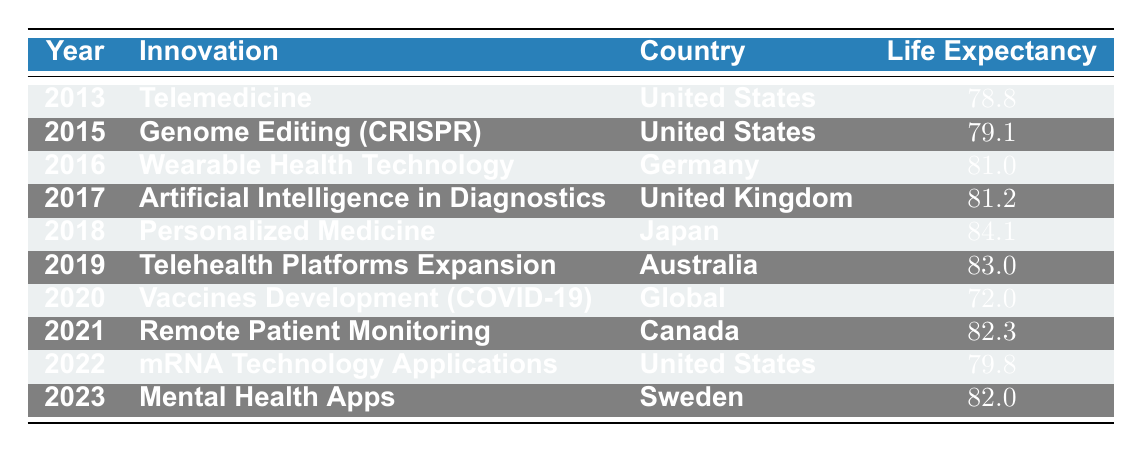What is the life expectancy in 2018? The table indicates that for the year 2018, the life expectancy associated with the innovation "Personalized Medicine" in Japan is 84.1.
Answer: 84.1 Which country introduced "Telemedicine" and what was the life expectancy at that time? According to the table, the United States introduced "Telemedicine" in 2013 with a life expectancy of 78.8.
Answer: United States, 78.8 Is the life expectancy in 2020 higher than in 2019? By comparing the life expectancies listed, in 2020 life expectancy was 72.0, while in 2019 it was 83.0, thus 72.0 is not higher than 83.0.
Answer: No What is the average life expectancy of all innovations listed for the year 2021 and later? The life expectancies for 2021 (82.3), 2022 (79.8), and 2023 (82.0) sum up to 244.1. There are three data points, so the average is 244.1/3 = 81.37.
Answer: 81.37 Which innovation had the highest life expectancy and what was that value? Looking through the table, the innovation with the highest life expectancy is "Personalized Medicine" in Japan in 2018, which is 84.1.
Answer: 84.1 Did "Wearable Health Technology" result in a life expectancy greater than 80? The table shows that "Wearable Health Technology" in 2016 had a life expectancy of 81.0, which is indeed greater than 80.
Answer: Yes What is the difference in life expectancy between the years 2018 and 2021? From the table, in 2018, the life expectancy was 84.1, while in 2021 it was 82.3. To find the difference: 84.1 - 82.3 = 1.8.
Answer: 1.8 Was "Genome Editing (CRISPR)" introduced in a year where life expectancy was below 80? The table indicates that "Genome Editing (CRISPR)" was introduced in 2015 with a life expectancy of 79.1, which is below 80.
Answer: Yes How many innovations resulted in a life expectancy of 80 or above from 2013 to 2023? By examining the table, the innovations that led to life expectancies of 80 or above are in the years 2016 (81.0), 2017 (81.2), 2018 (84.1), 2019 (83.0), 2021 (82.3), and 2023 (82.0)—totaling six innovations.
Answer: 6 